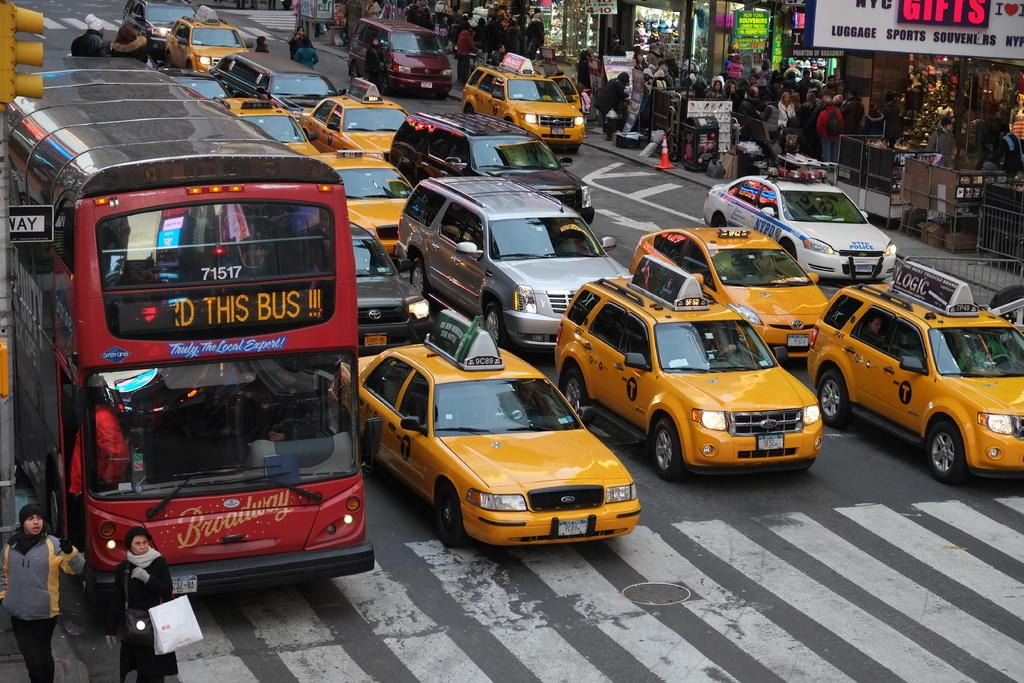Provide a one-sentence caption for the provided image. A large, red bus that says Truly The Local Export on the front is in the furthest lane of a road full of Taxi cab's. 